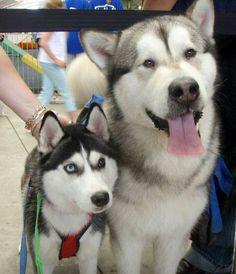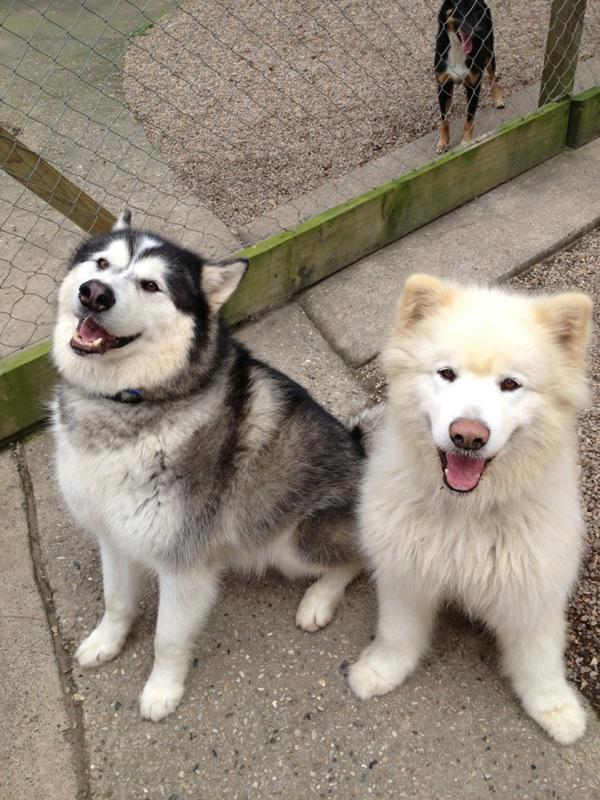The first image is the image on the left, the second image is the image on the right. Evaluate the accuracy of this statement regarding the images: "At least one dog has its mouth open.". Is it true? Answer yes or no. Yes. 